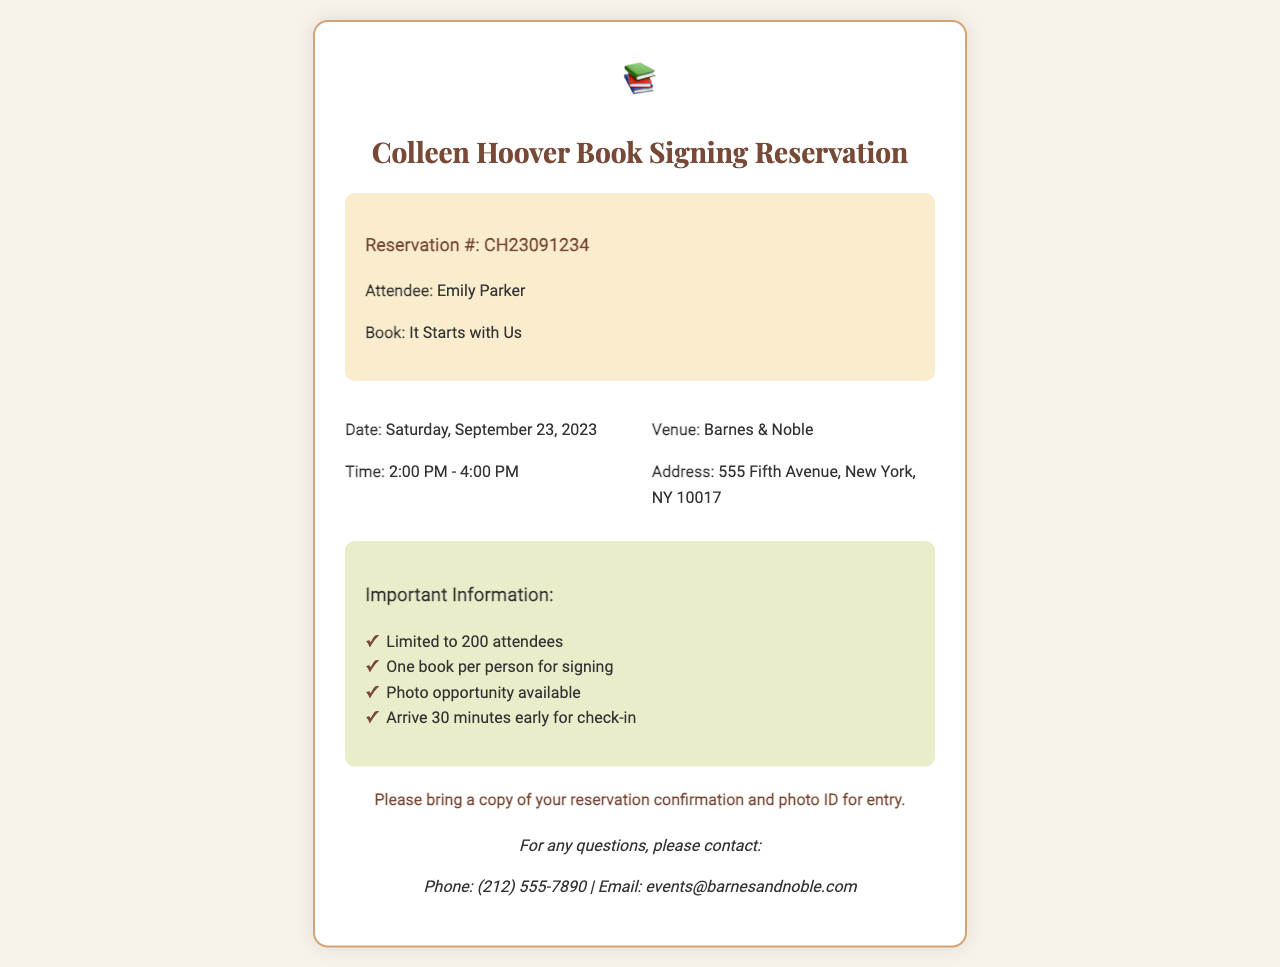What is the reservation number? The reservation number is found in the reservation details section of the document.
Answer: CH23091234 What is the date of the event? The date is specified in the event info section.
Answer: Saturday, September 23, 2023 What time does the book signing event start? The start time is mentioned in the event info section.
Answer: 2:00 PM Where is the venue located? The venue is discussed in the event info section, containing the name and address.
Answer: Barnes & Noble How many attendees are allowed? This information is given in the additional info section.
Answer: 200 attendees What should attendees bring for entry? The instructions for entry detail what is needed.
Answer: Reservation confirmation and photo ID What is the contact phone number for questions? The contact information includes a phone number for inquiries.
Answer: (212) 555-7890 How long is the event scheduled to last? The duration can be calculated from the start time and end time in the document.
Answer: 2 hours What book will be signed at the event? The book is mentioned in the reservation details section.
Answer: It Starts with Us 